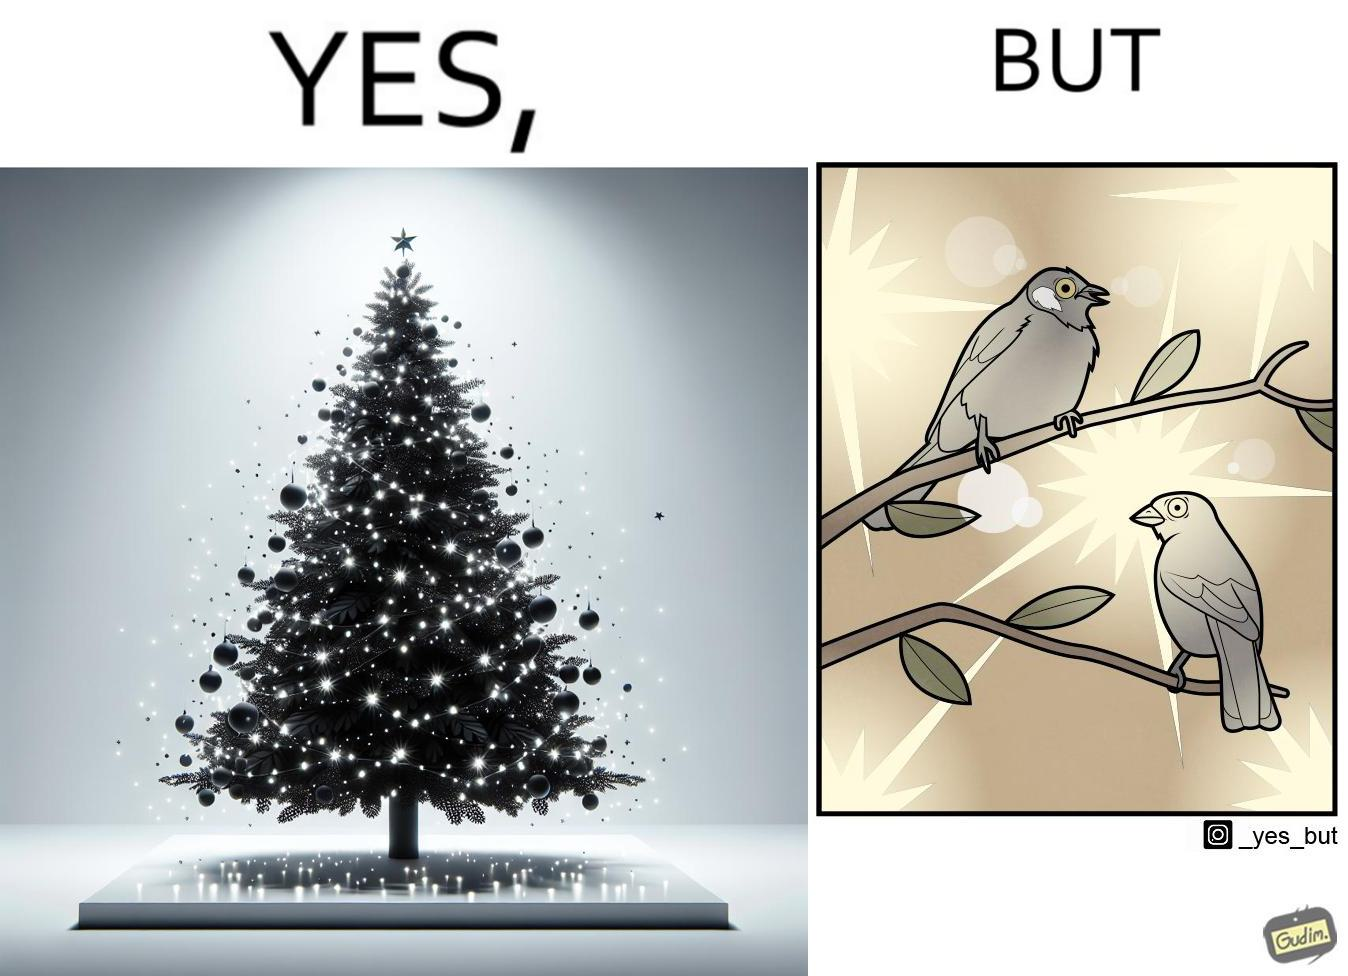What is shown in this image? The images are ironic since they show how putting a lot of lights as decorations on trees make them beautiful to look at for us but cause trouble to the birds who actually live on trees for no good reason 